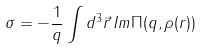<formula> <loc_0><loc_0><loc_500><loc_500>\sigma = - \frac { 1 } { q } \int { d ^ { 3 } \vec { r } \, I m \Pi ( q , \rho ( r ) ) }</formula> 